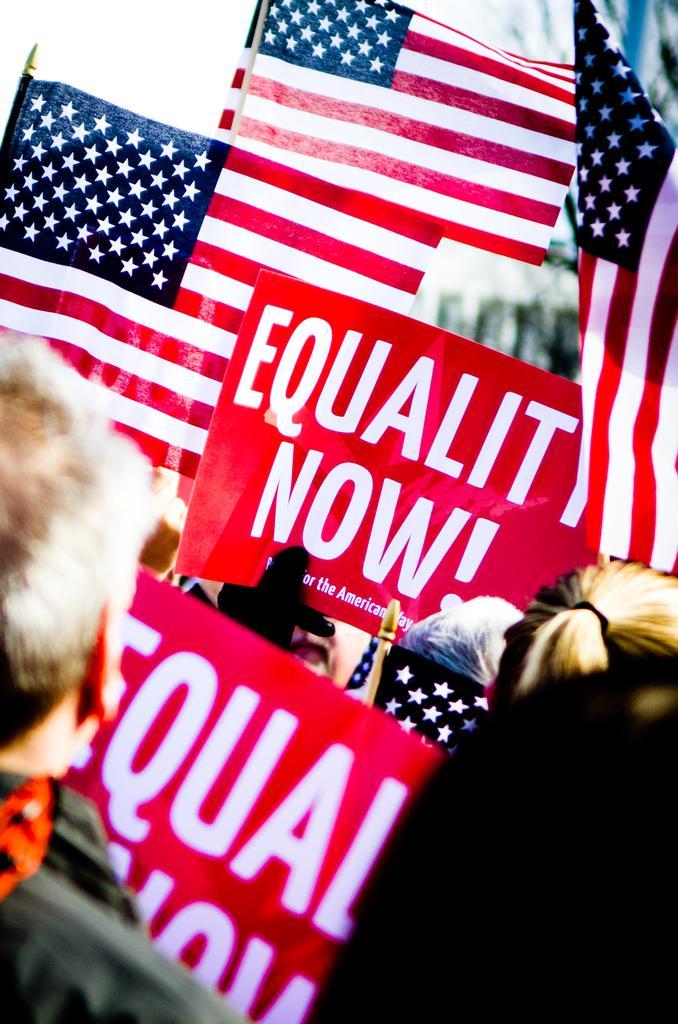In one or two sentences, can you explain what this image depicts? In this image I can see few people wearing the dresses and holding the banners and flags. I can see these banners and boards are in red, white and navy blue color. And there is a blurred background. 